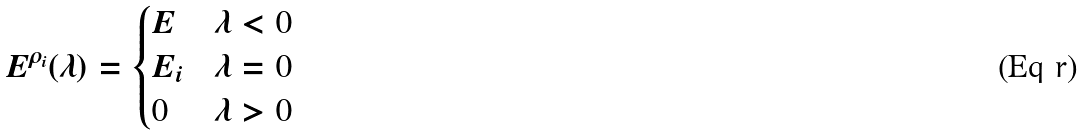<formula> <loc_0><loc_0><loc_500><loc_500>E ^ { \rho _ { i } } ( \lambda ) = \begin{cases} E & \lambda < 0 \\ E _ { i } & \lambda = 0 \\ 0 & \lambda > 0 \end{cases}</formula> 